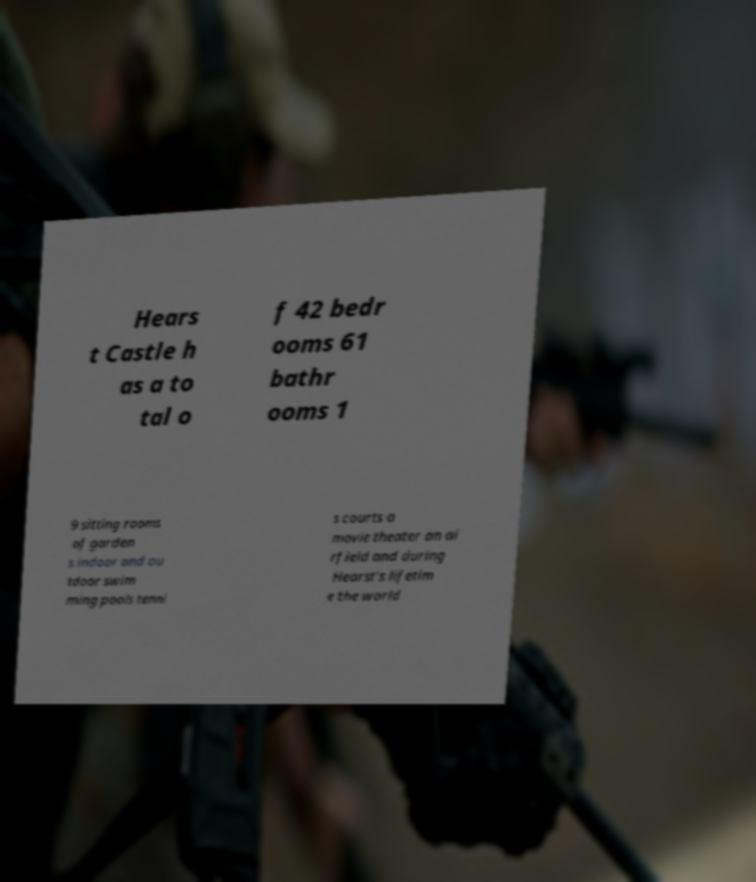Please read and relay the text visible in this image. What does it say? Hears t Castle h as a to tal o f 42 bedr ooms 61 bathr ooms 1 9 sitting rooms of garden s indoor and ou tdoor swim ming pools tenni s courts a movie theater an ai rfield and during Hearst’s lifetim e the world 